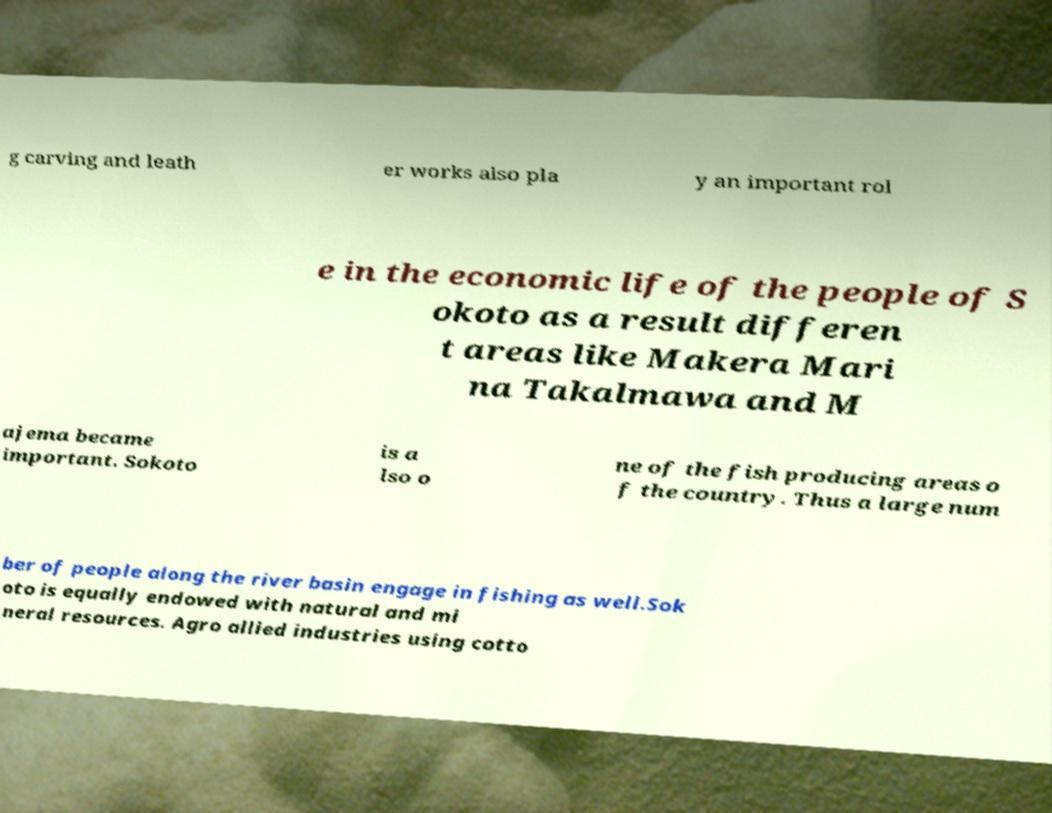For documentation purposes, I need the text within this image transcribed. Could you provide that? g carving and leath er works also pla y an important rol e in the economic life of the people of S okoto as a result differen t areas like Makera Mari na Takalmawa and M ajema became important. Sokoto is a lso o ne of the fish producing areas o f the country. Thus a large num ber of people along the river basin engage in fishing as well.Sok oto is equally endowed with natural and mi neral resources. Agro allied industries using cotto 